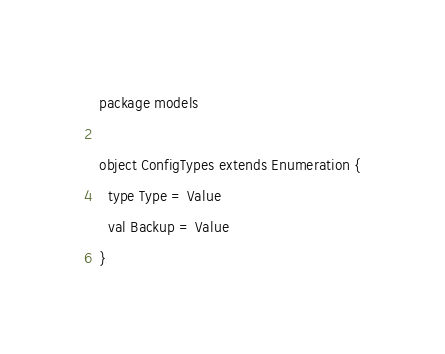<code> <loc_0><loc_0><loc_500><loc_500><_Scala_>package models

object ConfigTypes extends Enumeration {
  type Type = Value
  val Backup = Value
}
</code> 